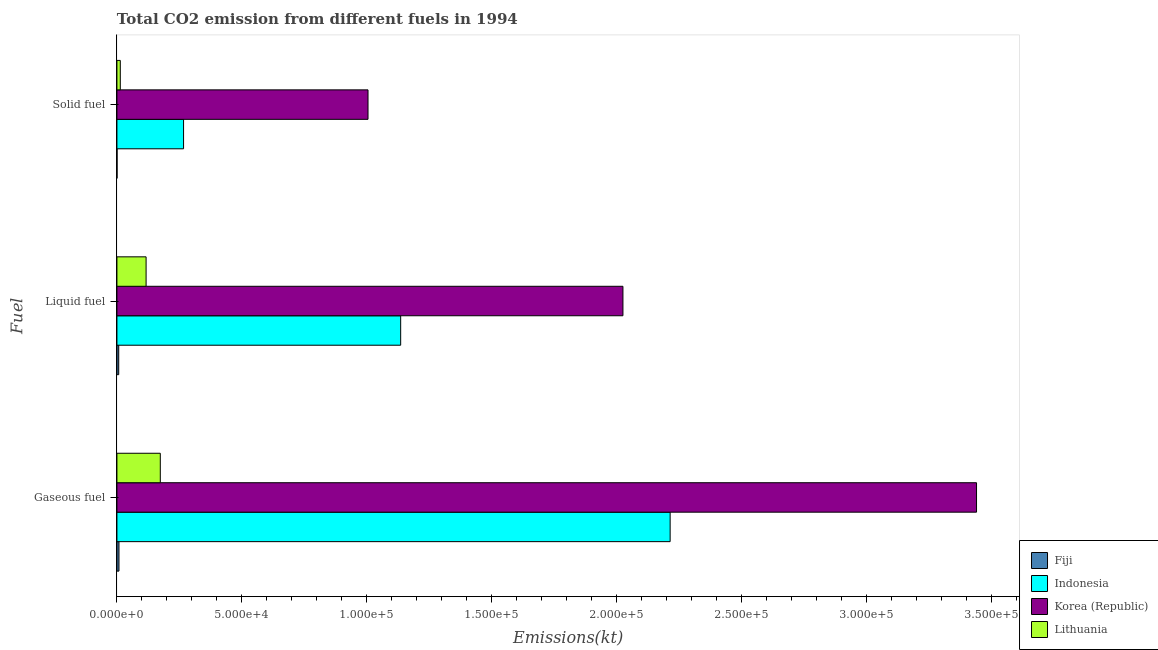How many different coloured bars are there?
Provide a short and direct response. 4. How many groups of bars are there?
Your response must be concise. 3. Are the number of bars per tick equal to the number of legend labels?
Offer a terse response. Yes. What is the label of the 3rd group of bars from the top?
Give a very brief answer. Gaseous fuel. What is the amount of co2 emissions from solid fuel in Fiji?
Your answer should be compact. 51.34. Across all countries, what is the maximum amount of co2 emissions from liquid fuel?
Offer a terse response. 2.03e+05. Across all countries, what is the minimum amount of co2 emissions from solid fuel?
Your answer should be very brief. 51.34. In which country was the amount of co2 emissions from gaseous fuel maximum?
Your response must be concise. Korea (Republic). In which country was the amount of co2 emissions from solid fuel minimum?
Provide a short and direct response. Fiji. What is the total amount of co2 emissions from gaseous fuel in the graph?
Provide a short and direct response. 5.84e+05. What is the difference between the amount of co2 emissions from liquid fuel in Lithuania and that in Korea (Republic)?
Offer a very short reply. -1.91e+05. What is the difference between the amount of co2 emissions from solid fuel in Korea (Republic) and the amount of co2 emissions from gaseous fuel in Indonesia?
Keep it short and to the point. -1.21e+05. What is the average amount of co2 emissions from liquid fuel per country?
Provide a succinct answer. 8.21e+04. What is the difference between the amount of co2 emissions from liquid fuel and amount of co2 emissions from solid fuel in Korea (Republic)?
Keep it short and to the point. 1.02e+05. What is the ratio of the amount of co2 emissions from solid fuel in Indonesia to that in Fiji?
Your answer should be compact. 519.5. Is the amount of co2 emissions from liquid fuel in Fiji less than that in Korea (Republic)?
Offer a terse response. Yes. Is the difference between the amount of co2 emissions from gaseous fuel in Lithuania and Fiji greater than the difference between the amount of co2 emissions from liquid fuel in Lithuania and Fiji?
Offer a terse response. Yes. What is the difference between the highest and the second highest amount of co2 emissions from solid fuel?
Your answer should be compact. 7.38e+04. What is the difference between the highest and the lowest amount of co2 emissions from liquid fuel?
Provide a succinct answer. 2.02e+05. What does the 2nd bar from the top in Gaseous fuel represents?
Offer a terse response. Korea (Republic). What does the 1st bar from the bottom in Solid fuel represents?
Provide a short and direct response. Fiji. Is it the case that in every country, the sum of the amount of co2 emissions from gaseous fuel and amount of co2 emissions from liquid fuel is greater than the amount of co2 emissions from solid fuel?
Ensure brevity in your answer.  Yes. Are the values on the major ticks of X-axis written in scientific E-notation?
Ensure brevity in your answer.  Yes. Where does the legend appear in the graph?
Provide a succinct answer. Bottom right. How are the legend labels stacked?
Your answer should be compact. Vertical. What is the title of the graph?
Provide a short and direct response. Total CO2 emission from different fuels in 1994. What is the label or title of the X-axis?
Ensure brevity in your answer.  Emissions(kt). What is the label or title of the Y-axis?
Ensure brevity in your answer.  Fuel. What is the Emissions(kt) of Fiji in Gaseous fuel?
Give a very brief answer. 817.74. What is the Emissions(kt) of Indonesia in Gaseous fuel?
Provide a short and direct response. 2.21e+05. What is the Emissions(kt) in Korea (Republic) in Gaseous fuel?
Provide a succinct answer. 3.44e+05. What is the Emissions(kt) in Lithuania in Gaseous fuel?
Keep it short and to the point. 1.74e+04. What is the Emissions(kt) of Fiji in Liquid fuel?
Your answer should be very brief. 718.73. What is the Emissions(kt) in Indonesia in Liquid fuel?
Offer a very short reply. 1.14e+05. What is the Emissions(kt) of Korea (Republic) in Liquid fuel?
Your response must be concise. 2.03e+05. What is the Emissions(kt) in Lithuania in Liquid fuel?
Ensure brevity in your answer.  1.17e+04. What is the Emissions(kt) of Fiji in Solid fuel?
Make the answer very short. 51.34. What is the Emissions(kt) of Indonesia in Solid fuel?
Your response must be concise. 2.67e+04. What is the Emissions(kt) in Korea (Republic) in Solid fuel?
Ensure brevity in your answer.  1.00e+05. What is the Emissions(kt) of Lithuania in Solid fuel?
Your answer should be very brief. 1353.12. Across all Fuel, what is the maximum Emissions(kt) of Fiji?
Your answer should be very brief. 817.74. Across all Fuel, what is the maximum Emissions(kt) of Indonesia?
Provide a short and direct response. 2.21e+05. Across all Fuel, what is the maximum Emissions(kt) in Korea (Republic)?
Ensure brevity in your answer.  3.44e+05. Across all Fuel, what is the maximum Emissions(kt) of Lithuania?
Your answer should be very brief. 1.74e+04. Across all Fuel, what is the minimum Emissions(kt) of Fiji?
Make the answer very short. 51.34. Across all Fuel, what is the minimum Emissions(kt) of Indonesia?
Your answer should be very brief. 2.67e+04. Across all Fuel, what is the minimum Emissions(kt) in Korea (Republic)?
Offer a terse response. 1.00e+05. Across all Fuel, what is the minimum Emissions(kt) in Lithuania?
Your response must be concise. 1353.12. What is the total Emissions(kt) of Fiji in the graph?
Give a very brief answer. 1587.81. What is the total Emissions(kt) in Indonesia in the graph?
Your answer should be compact. 3.62e+05. What is the total Emissions(kt) of Korea (Republic) in the graph?
Give a very brief answer. 6.47e+05. What is the total Emissions(kt) of Lithuania in the graph?
Provide a succinct answer. 3.04e+04. What is the difference between the Emissions(kt) of Fiji in Gaseous fuel and that in Liquid fuel?
Provide a short and direct response. 99.01. What is the difference between the Emissions(kt) in Indonesia in Gaseous fuel and that in Liquid fuel?
Provide a short and direct response. 1.08e+05. What is the difference between the Emissions(kt) of Korea (Republic) in Gaseous fuel and that in Liquid fuel?
Ensure brevity in your answer.  1.42e+05. What is the difference between the Emissions(kt) of Lithuania in Gaseous fuel and that in Liquid fuel?
Offer a very short reply. 5683.85. What is the difference between the Emissions(kt) of Fiji in Gaseous fuel and that in Solid fuel?
Offer a terse response. 766.4. What is the difference between the Emissions(kt) in Indonesia in Gaseous fuel and that in Solid fuel?
Your answer should be compact. 1.95e+05. What is the difference between the Emissions(kt) of Korea (Republic) in Gaseous fuel and that in Solid fuel?
Ensure brevity in your answer.  2.44e+05. What is the difference between the Emissions(kt) in Lithuania in Gaseous fuel and that in Solid fuel?
Make the answer very short. 1.60e+04. What is the difference between the Emissions(kt) of Fiji in Liquid fuel and that in Solid fuel?
Make the answer very short. 667.39. What is the difference between the Emissions(kt) of Indonesia in Liquid fuel and that in Solid fuel?
Offer a very short reply. 8.69e+04. What is the difference between the Emissions(kt) in Korea (Republic) in Liquid fuel and that in Solid fuel?
Offer a terse response. 1.02e+05. What is the difference between the Emissions(kt) in Lithuania in Liquid fuel and that in Solid fuel?
Provide a short and direct response. 1.03e+04. What is the difference between the Emissions(kt) of Fiji in Gaseous fuel and the Emissions(kt) of Indonesia in Liquid fuel?
Keep it short and to the point. -1.13e+05. What is the difference between the Emissions(kt) in Fiji in Gaseous fuel and the Emissions(kt) in Korea (Republic) in Liquid fuel?
Offer a terse response. -2.02e+05. What is the difference between the Emissions(kt) in Fiji in Gaseous fuel and the Emissions(kt) in Lithuania in Liquid fuel?
Provide a succinct answer. -1.09e+04. What is the difference between the Emissions(kt) in Indonesia in Gaseous fuel and the Emissions(kt) in Korea (Republic) in Liquid fuel?
Your response must be concise. 1.89e+04. What is the difference between the Emissions(kt) of Indonesia in Gaseous fuel and the Emissions(kt) of Lithuania in Liquid fuel?
Your response must be concise. 2.10e+05. What is the difference between the Emissions(kt) in Korea (Republic) in Gaseous fuel and the Emissions(kt) in Lithuania in Liquid fuel?
Make the answer very short. 3.32e+05. What is the difference between the Emissions(kt) in Fiji in Gaseous fuel and the Emissions(kt) in Indonesia in Solid fuel?
Keep it short and to the point. -2.59e+04. What is the difference between the Emissions(kt) of Fiji in Gaseous fuel and the Emissions(kt) of Korea (Republic) in Solid fuel?
Your answer should be compact. -9.97e+04. What is the difference between the Emissions(kt) in Fiji in Gaseous fuel and the Emissions(kt) in Lithuania in Solid fuel?
Provide a succinct answer. -535.38. What is the difference between the Emissions(kt) in Indonesia in Gaseous fuel and the Emissions(kt) in Korea (Republic) in Solid fuel?
Keep it short and to the point. 1.21e+05. What is the difference between the Emissions(kt) in Indonesia in Gaseous fuel and the Emissions(kt) in Lithuania in Solid fuel?
Your response must be concise. 2.20e+05. What is the difference between the Emissions(kt) of Korea (Republic) in Gaseous fuel and the Emissions(kt) of Lithuania in Solid fuel?
Provide a short and direct response. 3.43e+05. What is the difference between the Emissions(kt) in Fiji in Liquid fuel and the Emissions(kt) in Indonesia in Solid fuel?
Your answer should be very brief. -2.60e+04. What is the difference between the Emissions(kt) in Fiji in Liquid fuel and the Emissions(kt) in Korea (Republic) in Solid fuel?
Keep it short and to the point. -9.98e+04. What is the difference between the Emissions(kt) in Fiji in Liquid fuel and the Emissions(kt) in Lithuania in Solid fuel?
Your response must be concise. -634.39. What is the difference between the Emissions(kt) of Indonesia in Liquid fuel and the Emissions(kt) of Korea (Republic) in Solid fuel?
Your answer should be compact. 1.31e+04. What is the difference between the Emissions(kt) of Indonesia in Liquid fuel and the Emissions(kt) of Lithuania in Solid fuel?
Your response must be concise. 1.12e+05. What is the difference between the Emissions(kt) of Korea (Republic) in Liquid fuel and the Emissions(kt) of Lithuania in Solid fuel?
Provide a succinct answer. 2.01e+05. What is the average Emissions(kt) in Fiji per Fuel?
Offer a terse response. 529.27. What is the average Emissions(kt) in Indonesia per Fuel?
Ensure brevity in your answer.  1.21e+05. What is the average Emissions(kt) in Korea (Republic) per Fuel?
Make the answer very short. 2.16e+05. What is the average Emissions(kt) in Lithuania per Fuel?
Give a very brief answer. 1.01e+04. What is the difference between the Emissions(kt) of Fiji and Emissions(kt) of Indonesia in Gaseous fuel?
Ensure brevity in your answer.  -2.21e+05. What is the difference between the Emissions(kt) in Fiji and Emissions(kt) in Korea (Republic) in Gaseous fuel?
Give a very brief answer. -3.43e+05. What is the difference between the Emissions(kt) of Fiji and Emissions(kt) of Lithuania in Gaseous fuel?
Offer a very short reply. -1.65e+04. What is the difference between the Emissions(kt) of Indonesia and Emissions(kt) of Korea (Republic) in Gaseous fuel?
Your answer should be very brief. -1.23e+05. What is the difference between the Emissions(kt) of Indonesia and Emissions(kt) of Lithuania in Gaseous fuel?
Ensure brevity in your answer.  2.04e+05. What is the difference between the Emissions(kt) of Korea (Republic) and Emissions(kt) of Lithuania in Gaseous fuel?
Offer a terse response. 3.27e+05. What is the difference between the Emissions(kt) in Fiji and Emissions(kt) in Indonesia in Liquid fuel?
Keep it short and to the point. -1.13e+05. What is the difference between the Emissions(kt) of Fiji and Emissions(kt) of Korea (Republic) in Liquid fuel?
Your answer should be very brief. -2.02e+05. What is the difference between the Emissions(kt) of Fiji and Emissions(kt) of Lithuania in Liquid fuel?
Provide a succinct answer. -1.10e+04. What is the difference between the Emissions(kt) of Indonesia and Emissions(kt) of Korea (Republic) in Liquid fuel?
Keep it short and to the point. -8.90e+04. What is the difference between the Emissions(kt) in Indonesia and Emissions(kt) in Lithuania in Liquid fuel?
Ensure brevity in your answer.  1.02e+05. What is the difference between the Emissions(kt) of Korea (Republic) and Emissions(kt) of Lithuania in Liquid fuel?
Provide a short and direct response. 1.91e+05. What is the difference between the Emissions(kt) in Fiji and Emissions(kt) in Indonesia in Solid fuel?
Keep it short and to the point. -2.66e+04. What is the difference between the Emissions(kt) of Fiji and Emissions(kt) of Korea (Republic) in Solid fuel?
Provide a short and direct response. -1.00e+05. What is the difference between the Emissions(kt) in Fiji and Emissions(kt) in Lithuania in Solid fuel?
Your answer should be compact. -1301.79. What is the difference between the Emissions(kt) in Indonesia and Emissions(kt) in Korea (Republic) in Solid fuel?
Make the answer very short. -7.38e+04. What is the difference between the Emissions(kt) of Indonesia and Emissions(kt) of Lithuania in Solid fuel?
Your answer should be very brief. 2.53e+04. What is the difference between the Emissions(kt) in Korea (Republic) and Emissions(kt) in Lithuania in Solid fuel?
Keep it short and to the point. 9.91e+04. What is the ratio of the Emissions(kt) of Fiji in Gaseous fuel to that in Liquid fuel?
Offer a very short reply. 1.14. What is the ratio of the Emissions(kt) of Indonesia in Gaseous fuel to that in Liquid fuel?
Make the answer very short. 1.95. What is the ratio of the Emissions(kt) in Korea (Republic) in Gaseous fuel to that in Liquid fuel?
Provide a short and direct response. 1.7. What is the ratio of the Emissions(kt) in Lithuania in Gaseous fuel to that in Liquid fuel?
Provide a short and direct response. 1.49. What is the ratio of the Emissions(kt) of Fiji in Gaseous fuel to that in Solid fuel?
Provide a short and direct response. 15.93. What is the ratio of the Emissions(kt) in Indonesia in Gaseous fuel to that in Solid fuel?
Your answer should be compact. 8.3. What is the ratio of the Emissions(kt) in Korea (Republic) in Gaseous fuel to that in Solid fuel?
Make the answer very short. 3.42. What is the ratio of the Emissions(kt) in Lithuania in Gaseous fuel to that in Solid fuel?
Ensure brevity in your answer.  12.83. What is the ratio of the Emissions(kt) in Indonesia in Liquid fuel to that in Solid fuel?
Offer a terse response. 4.26. What is the ratio of the Emissions(kt) of Korea (Republic) in Liquid fuel to that in Solid fuel?
Your answer should be compact. 2.02. What is the ratio of the Emissions(kt) in Lithuania in Liquid fuel to that in Solid fuel?
Give a very brief answer. 8.63. What is the difference between the highest and the second highest Emissions(kt) of Fiji?
Your answer should be very brief. 99.01. What is the difference between the highest and the second highest Emissions(kt) of Indonesia?
Offer a terse response. 1.08e+05. What is the difference between the highest and the second highest Emissions(kt) in Korea (Republic)?
Make the answer very short. 1.42e+05. What is the difference between the highest and the second highest Emissions(kt) in Lithuania?
Your answer should be compact. 5683.85. What is the difference between the highest and the lowest Emissions(kt) of Fiji?
Keep it short and to the point. 766.4. What is the difference between the highest and the lowest Emissions(kt) of Indonesia?
Keep it short and to the point. 1.95e+05. What is the difference between the highest and the lowest Emissions(kt) of Korea (Republic)?
Your answer should be compact. 2.44e+05. What is the difference between the highest and the lowest Emissions(kt) of Lithuania?
Offer a terse response. 1.60e+04. 